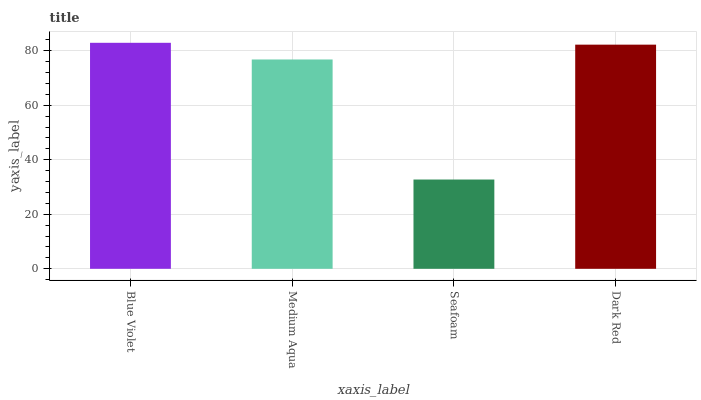Is Seafoam the minimum?
Answer yes or no. Yes. Is Blue Violet the maximum?
Answer yes or no. Yes. Is Medium Aqua the minimum?
Answer yes or no. No. Is Medium Aqua the maximum?
Answer yes or no. No. Is Blue Violet greater than Medium Aqua?
Answer yes or no. Yes. Is Medium Aqua less than Blue Violet?
Answer yes or no. Yes. Is Medium Aqua greater than Blue Violet?
Answer yes or no. No. Is Blue Violet less than Medium Aqua?
Answer yes or no. No. Is Dark Red the high median?
Answer yes or no. Yes. Is Medium Aqua the low median?
Answer yes or no. Yes. Is Seafoam the high median?
Answer yes or no. No. Is Dark Red the low median?
Answer yes or no. No. 